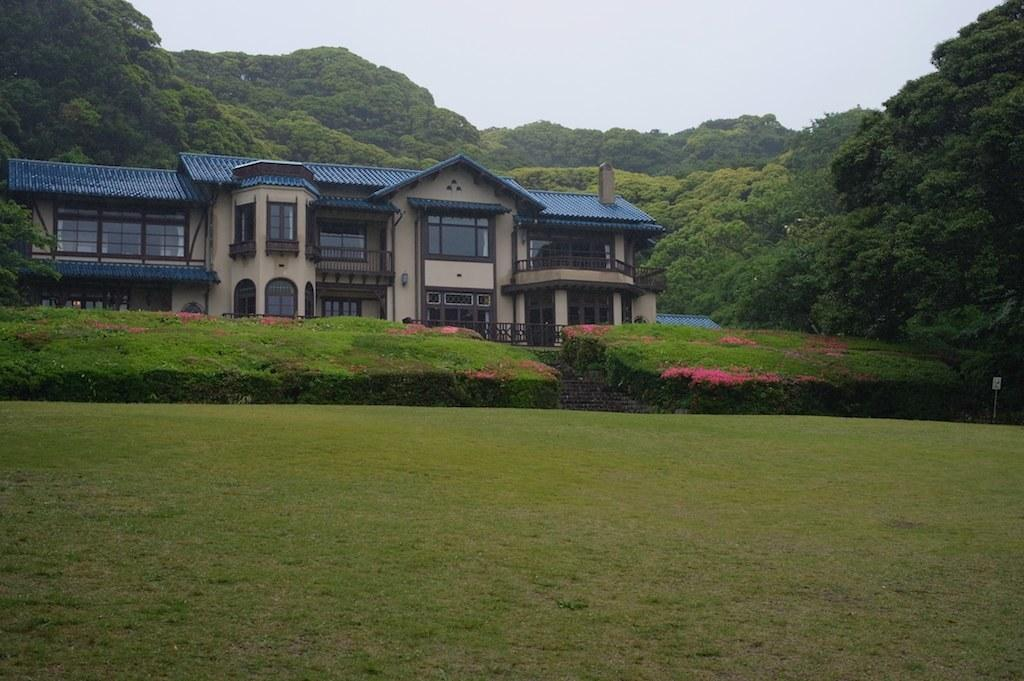What type of structure is present in the image? There is a house in the image. What features can be observed on the house? The house has windows, a roof, and a fence. Are there any architectural elements visible in the image? Yes, there are stairs in the image. What type of vegetation is present in the image? There are plants with flowers, a group of trees, and grass in the image. What is visible in the background of the image? The sky is visible in the image, and it looks cloudy. Can you hear anyone coughing in the image? There is no audible information in the image, so it is not possible to determine if anyone is coughing. 